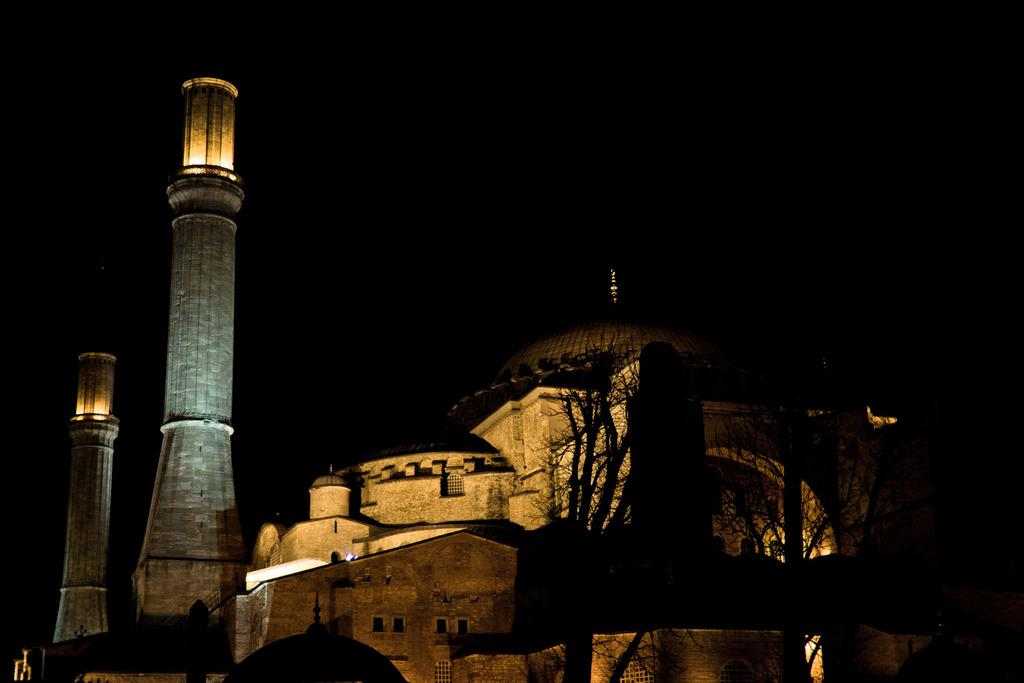What structures are present in the image? There are towers in the image. What type of vegetation can be seen in the image? There are trees in the image. Is there a bike advertisement visible in the image? There is no mention of a bike or an advertisement in the provided facts, so it cannot be determined if one is present in the image. 